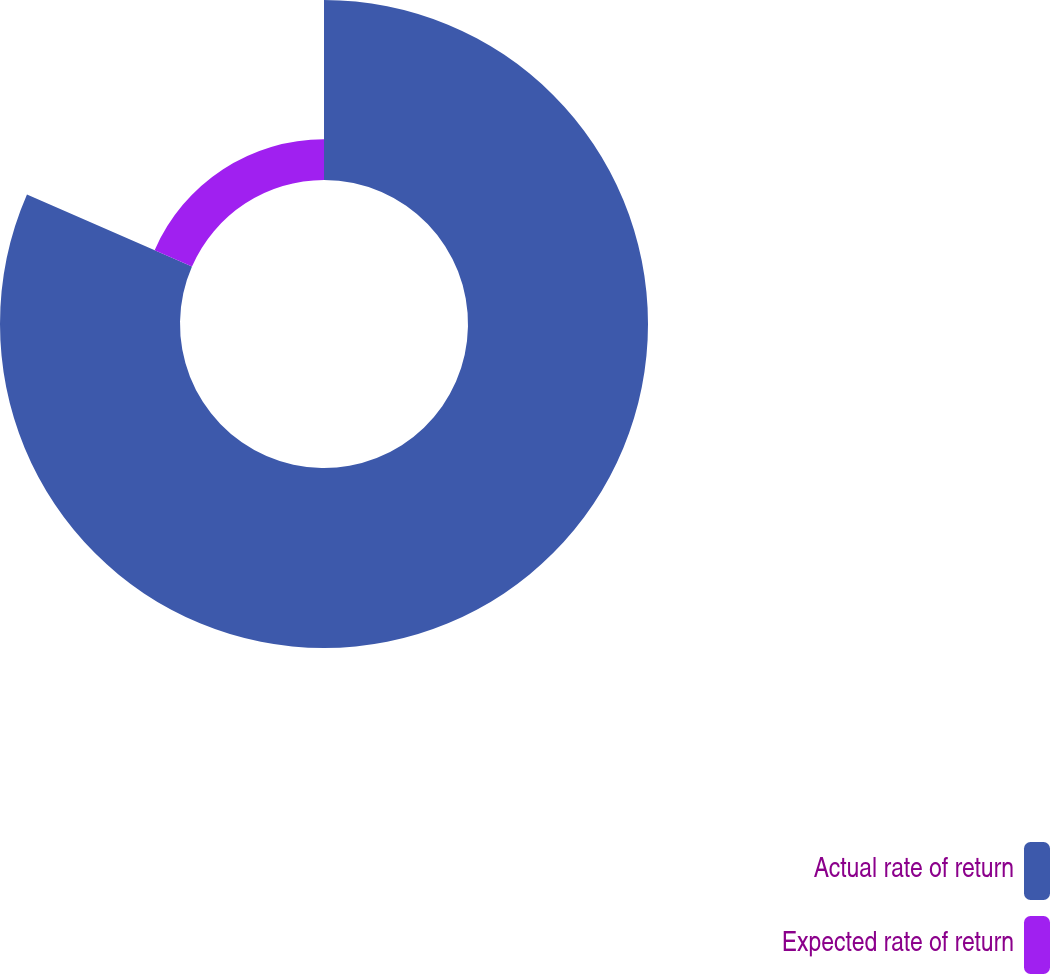Convert chart to OTSL. <chart><loc_0><loc_0><loc_500><loc_500><pie_chart><fcel>Actual rate of return<fcel>Expected rate of return<nl><fcel>81.54%<fcel>18.46%<nl></chart> 